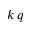Convert formula to latex. <formula><loc_0><loc_0><loc_500><loc_500>k \, q</formula> 